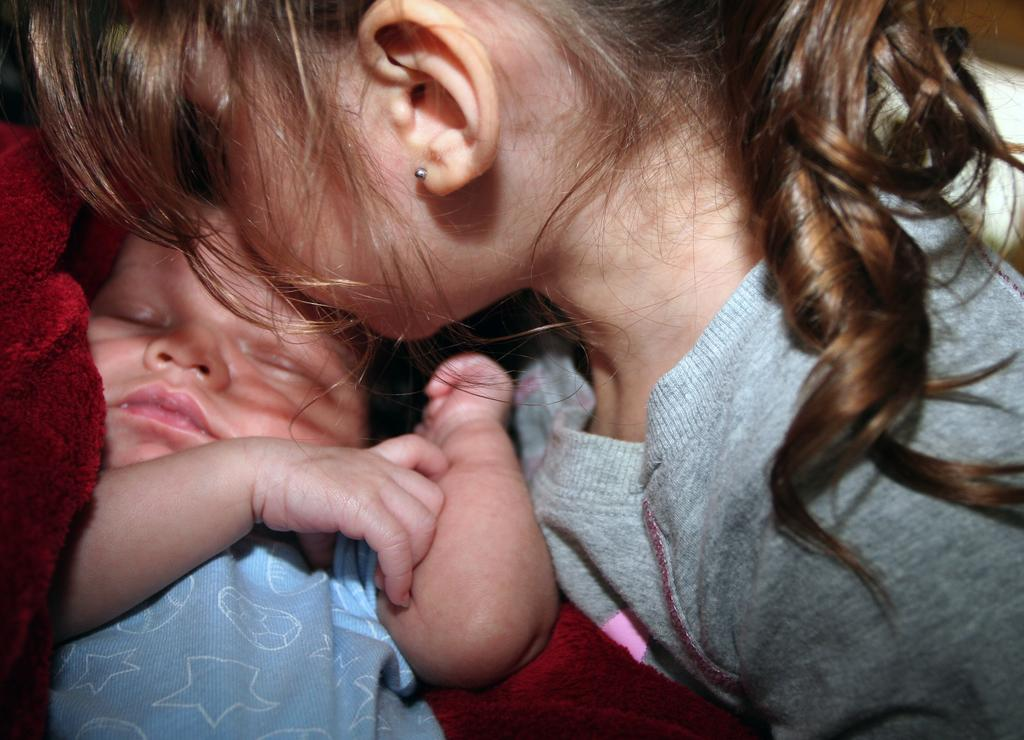What is the main subject of the image? The main subject of the image is the persons in the center. Can you describe the position of the kid in the image? The kid is sleeping on the left side of the image. What type of fowl can be seen interacting with the sleeping kid in the image? There is: There is no fowl present in the image; the kid is sleeping alone on the left side. 